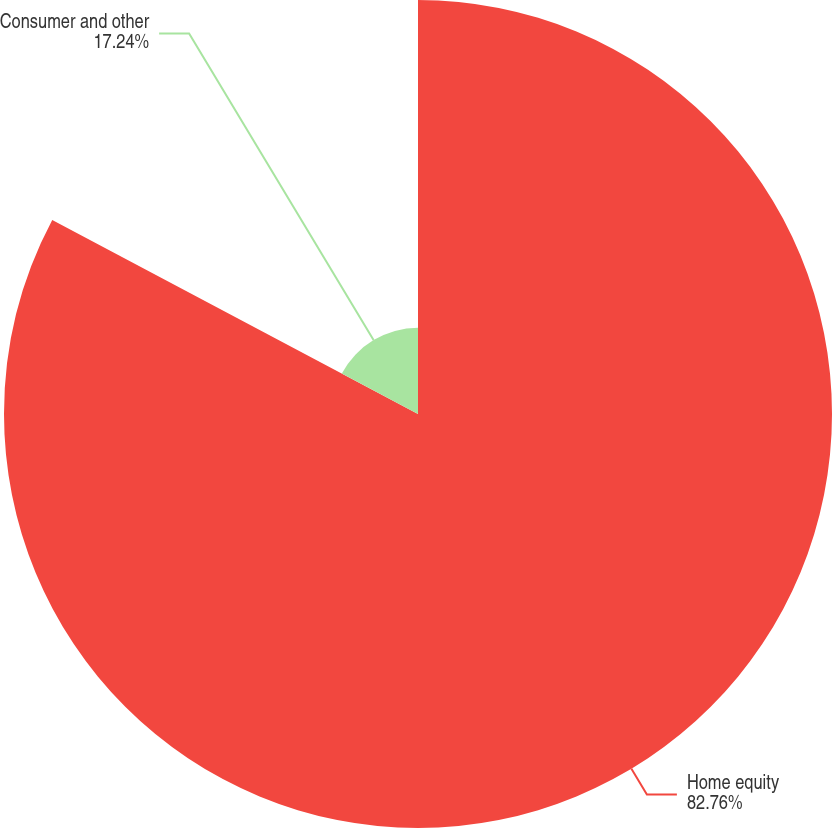Convert chart. <chart><loc_0><loc_0><loc_500><loc_500><pie_chart><fcel>Home equity<fcel>Consumer and other<nl><fcel>82.76%<fcel>17.24%<nl></chart> 